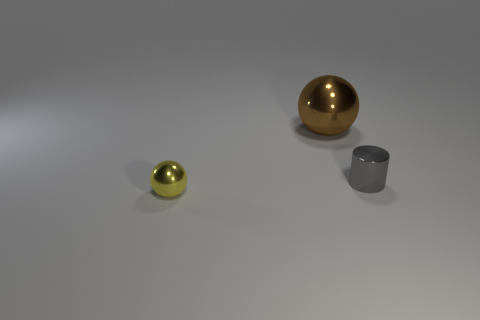Add 1 large brown objects. How many objects exist? 4 Subtract all spheres. How many objects are left? 1 Add 3 large brown spheres. How many large brown spheres exist? 4 Subtract 0 green blocks. How many objects are left? 3 Subtract all yellow metal things. Subtract all tiny yellow spheres. How many objects are left? 1 Add 3 gray things. How many gray things are left? 4 